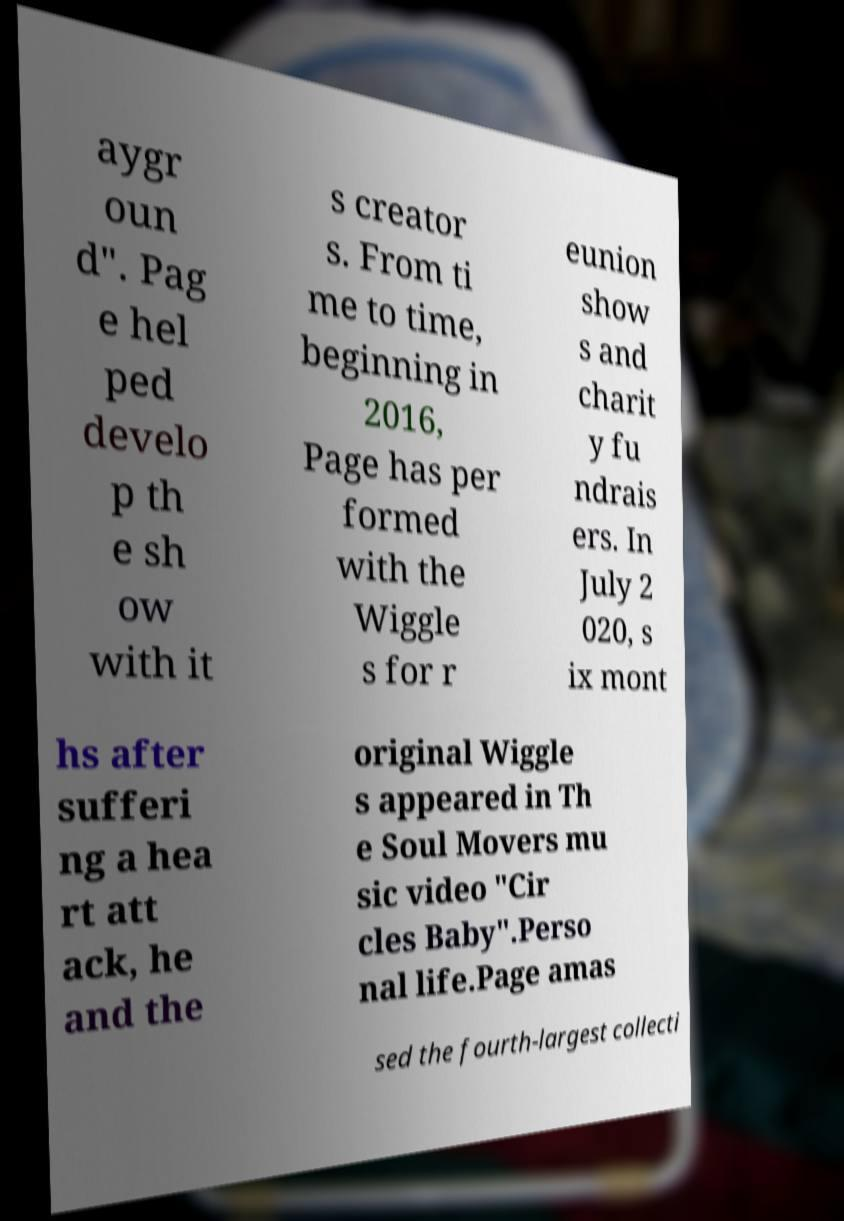For documentation purposes, I need the text within this image transcribed. Could you provide that? aygr oun d". Pag e hel ped develo p th e sh ow with it s creator s. From ti me to time, beginning in 2016, Page has per formed with the Wiggle s for r eunion show s and charit y fu ndrais ers. In July 2 020, s ix mont hs after sufferi ng a hea rt att ack, he and the original Wiggle s appeared in Th e Soul Movers mu sic video "Cir cles Baby".Perso nal life.Page amas sed the fourth-largest collecti 